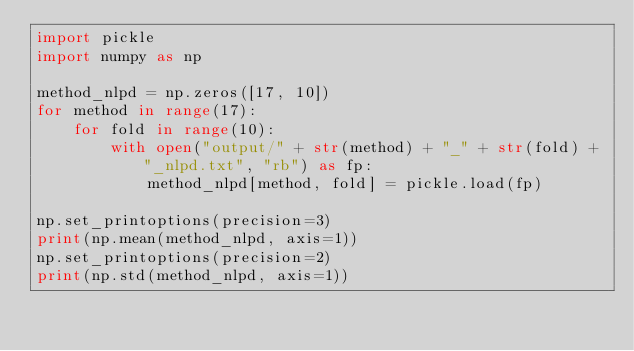Convert code to text. <code><loc_0><loc_0><loc_500><loc_500><_Python_>import pickle
import numpy as np

method_nlpd = np.zeros([17, 10])
for method in range(17):
    for fold in range(10):
        with open("output/" + str(method) + "_" + str(fold) + "_nlpd.txt", "rb") as fp:
            method_nlpd[method, fold] = pickle.load(fp)

np.set_printoptions(precision=3)
print(np.mean(method_nlpd, axis=1))
np.set_printoptions(precision=2)
print(np.std(method_nlpd, axis=1))
</code> 